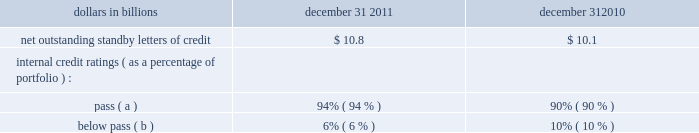Whether or not any claims asserted against us or others to whom we may have indemnification obligations , whether in the proceedings or other matters described above or otherwise , will have a material adverse effect on our results of operations in any future reporting period , which will depend on , among other things , the amount of the loss resulting from the claim and the amount of income otherwise reported for the reporting period .
See note 23 commitments and guarantees for additional information regarding the visa indemnification and our other obligations to provide indemnification , including to current and former officers , directors , employees and agents of pnc and companies we have acquired , including national city .
Note 23 commitments and guarantees equity funding and other commitments our unfunded commitments at december 31 , 2011 included private equity investments of $ 247 million , and other investments of $ 3 million .
Standby letters of credit we issue standby letters of credit and have risk participations in standby letters of credit and bankers 2019 acceptances issued by other financial institutions , in each case to support obligations of our customers to third parties , such as remarketing programs for customers 2019 variable rate demand notes .
Net outstanding standby letters of credit and internal credit ratings were as follows : net outstanding standby letters of credit dollars in billions december 31 december 31 .
( a ) indicates that expected risk of loss is currently low .
( b ) indicates a higher degree of risk of default .
If the customer fails to meet its financial or performance obligation to the third party under the terms of the contract or there is a need to support a remarketing program , then upon the request of the guaranteed party , we would be obligated to make payment to them .
The standby letters of credit and risk participations in standby letters of credit and bankers 2019 acceptances outstanding on december 31 , 2011 had terms ranging from less than 1 year to 7 years .
The aggregate maximum amount of future payments pnc could be required to make under outstanding standby letters of credit and risk participations in standby letters of credit and bankers 2019 acceptances was $ 14.4 billion at december 31 , 2011 , of which $ 7.4 billion support remarketing programs .
As of december 31 , 2011 , assets of $ 2.0 billion secured certain specifically identified standby letters of credit .
Recourse provisions from third parties of $ 3.6 billion were also available for this purpose as of december 31 , 2011 .
In addition , a portion of the remaining standby letters of credit and letter of credit risk participations issued on behalf of specific customers is also secured by collateral or guarantees that secure the customers 2019 other obligations to us .
The carrying amount of the liability for our obligations related to standby letters of credit and risk participations in standby letters of credit and bankers 2019 acceptances was $ 247 million at december 31 , 2011 .
Standby bond purchase agreements and other liquidity facilities we enter into standby bond purchase agreements to support municipal bond obligations .
At december 31 , 2011 , the aggregate of our commitments under these facilities was $ 543 million .
We also enter into certain other liquidity facilities to support individual pools of receivables acquired by commercial paper conduits .
At december 31 , 2011 , our total commitments under these facilities were $ 199 million .
Indemnifications we are a party to numerous acquisition or divestiture agreements under which we have purchased or sold , or agreed to purchase or sell , various types of assets .
These agreements can cover the purchase or sale of : 2022 entire businesses , 2022 loan portfolios , 2022 branch banks , 2022 partial interests in companies , or 2022 other types of assets .
These agreements generally include indemnification provisions under which we indemnify the third parties to these agreements against a variety of risks to the indemnified parties as a result of the transaction in question .
When pnc is the seller , the indemnification provisions will generally also provide the buyer with protection relating to the quality of the assets we are selling and the extent of any liabilities being assumed by the buyer .
Due to the nature of these indemnification provisions , we cannot quantify the total potential exposure to us resulting from them .
We provide indemnification in connection with securities offering transactions in which we are involved .
When we are the issuer of the securities , we provide indemnification to the underwriters or placement agents analogous to the indemnification provided to the purchasers of businesses from us , as described above .
When we are an underwriter or placement agent , we provide a limited indemnification to the issuer related to our actions in connection with the offering and , if there are other underwriters , indemnification to the other underwriters intended to result in an appropriate sharing of the risk of participating in the offering .
Due to the nature of these indemnification provisions , we cannot quantify the total potential exposure to us resulting from them .
In the ordinary course of business , we enter into certain types of agreements that include provisions for indemnifying third the pnc financial services group , inc .
2013 form 10-k 197 .
For the standby letters of credit , risk participations in standby letters of credit , and bankers 2019 acceptances outstanding on december 31 , 2011 , what was the difference between the minimum and maximum term in years? 
Computations: (7 - 1)
Answer: 6.0. 